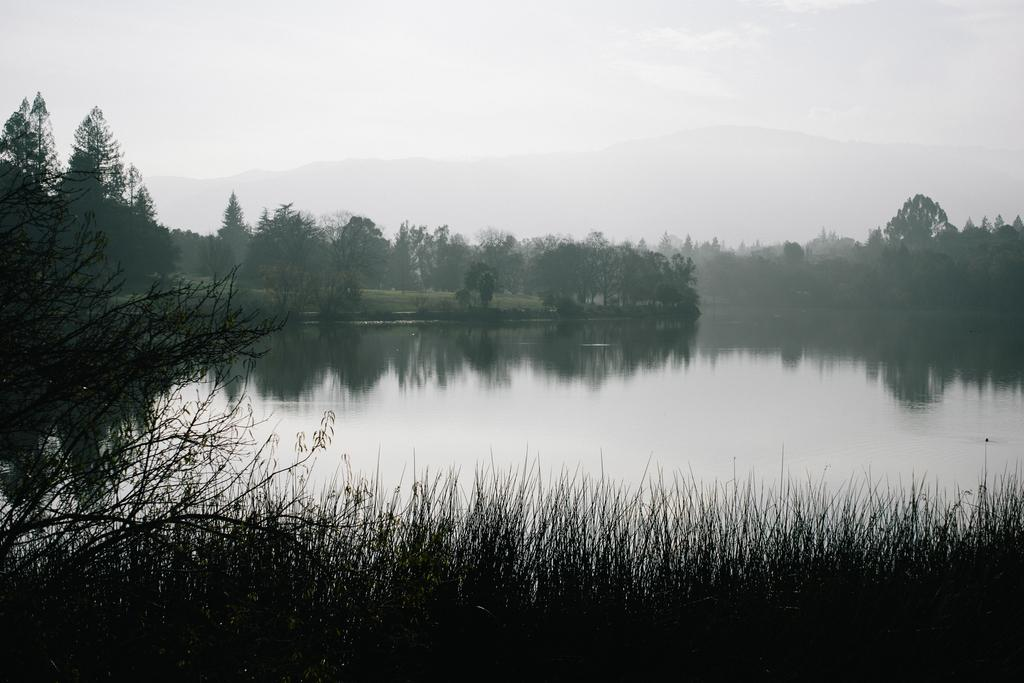What type of vegetation can be seen in the background of the image? There are trees in the background of the image. What is located in the center of the image? There is water in the center of the image. What type of ground cover is at the bottom of the image? There is grass at the bottom of the image. What part of the natural environment is visible at the top of the image? There is sky at the top of the image. What type of tool is the arm using in the image? There is no arm or tool present in the image. How many quarters are visible in the image? There are no quarters present in the image. 